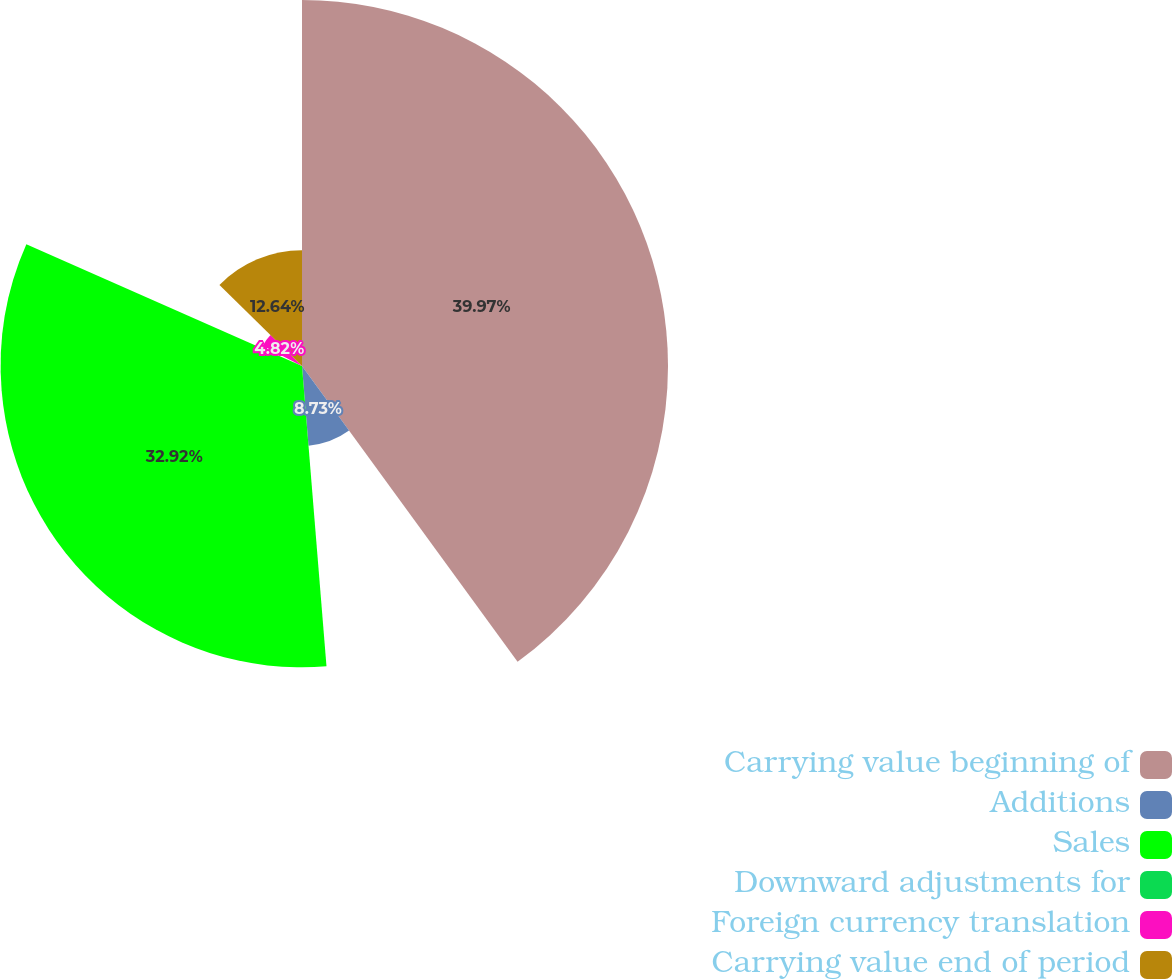Convert chart. <chart><loc_0><loc_0><loc_500><loc_500><pie_chart><fcel>Carrying value beginning of<fcel>Additions<fcel>Sales<fcel>Downward adjustments for<fcel>Foreign currency translation<fcel>Carrying value end of period<nl><fcel>39.98%<fcel>8.73%<fcel>32.92%<fcel>0.92%<fcel>4.82%<fcel>12.64%<nl></chart> 